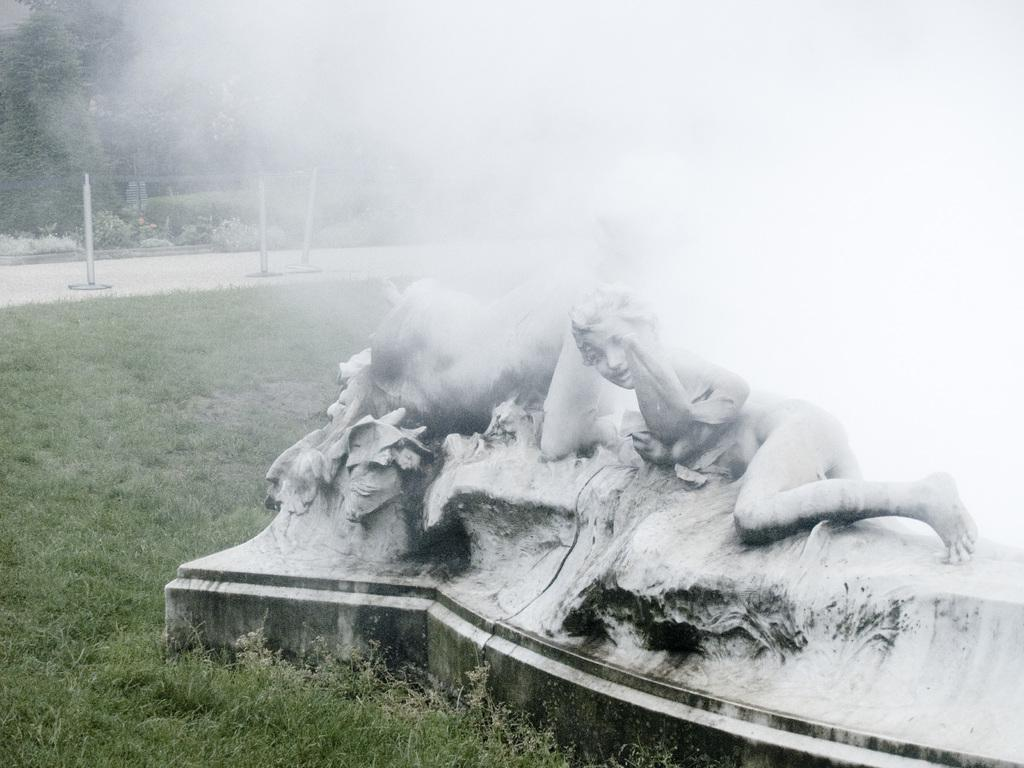What is the main subject in the center of the image? There is a statue in the center of the image. What can be seen in the background of the image? There are trees, poles, and a road in the background of the image. What type of vegetation is present at the bottom of the image? Grass is present at the bottom of the image. What type of advertisement can be seen on the statue in the image? There is no advertisement present on the statue in the image. Can you describe the self-portrait of the artist in the image? There is no self-portrait of the artist in the image; it features a statue. 